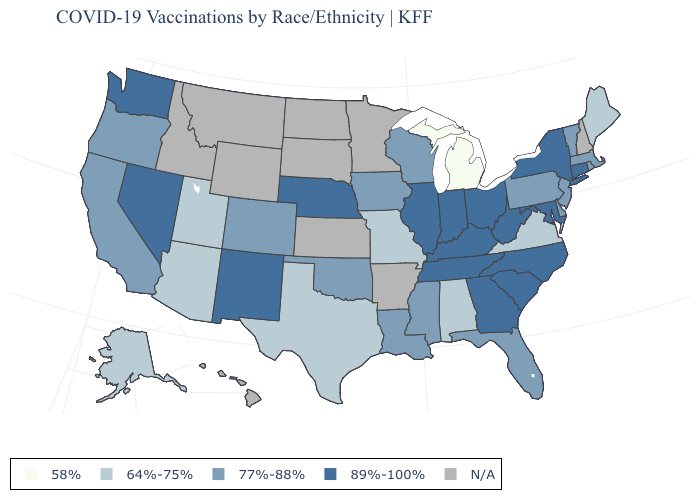What is the value of Oklahoma?
Write a very short answer. 77%-88%. Name the states that have a value in the range 89%-100%?
Keep it brief. Connecticut, Georgia, Illinois, Indiana, Kentucky, Maryland, Nebraska, Nevada, New Mexico, New York, North Carolina, Ohio, South Carolina, Tennessee, Washington, West Virginia. What is the highest value in the Northeast ?
Be succinct. 89%-100%. What is the lowest value in the MidWest?
Give a very brief answer. 58%. What is the value of West Virginia?
Give a very brief answer. 89%-100%. Name the states that have a value in the range 77%-88%?
Keep it brief. California, Colorado, Delaware, Florida, Iowa, Louisiana, Massachusetts, Mississippi, New Jersey, Oklahoma, Oregon, Pennsylvania, Rhode Island, Vermont, Wisconsin. What is the value of New Jersey?
Concise answer only. 77%-88%. Does the map have missing data?
Answer briefly. Yes. Among the states that border Oregon , does Nevada have the lowest value?
Give a very brief answer. No. Name the states that have a value in the range N/A?
Quick response, please. Arkansas, Hawaii, Idaho, Kansas, Minnesota, Montana, New Hampshire, North Dakota, South Dakota, Wyoming. Does Massachusetts have the highest value in the USA?
Give a very brief answer. No. 